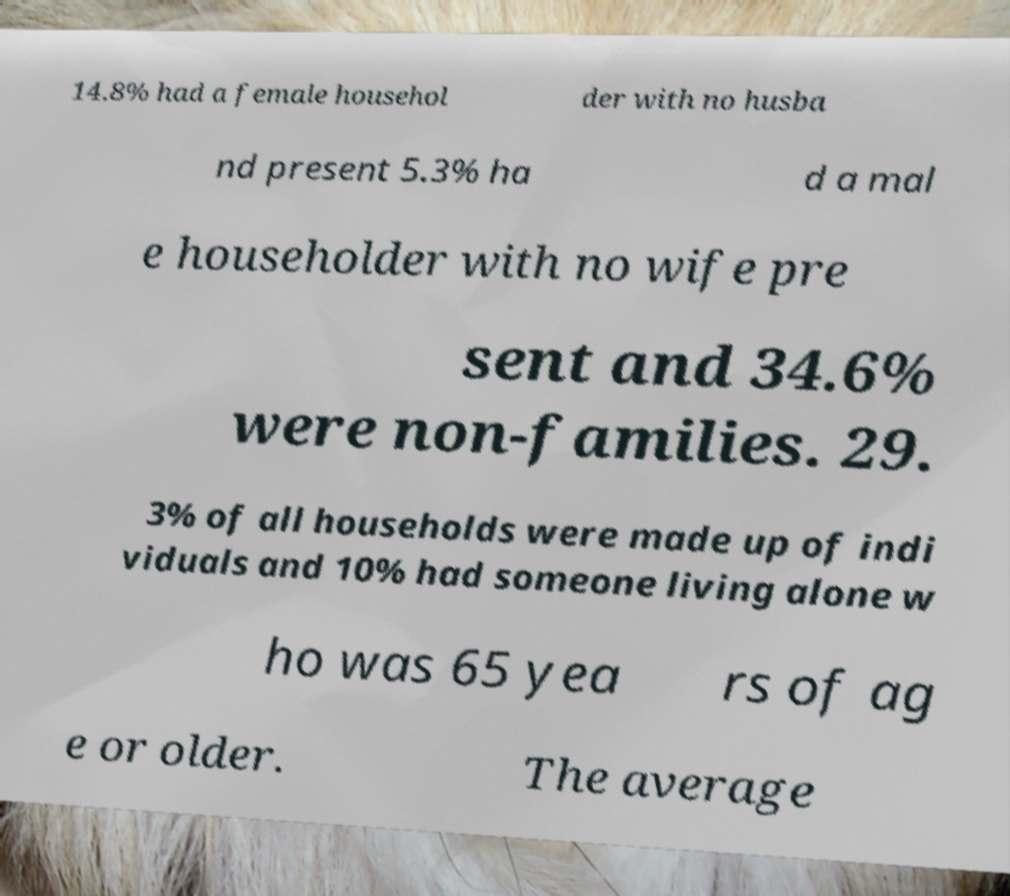Could you extract and type out the text from this image? 14.8% had a female househol der with no husba nd present 5.3% ha d a mal e householder with no wife pre sent and 34.6% were non-families. 29. 3% of all households were made up of indi viduals and 10% had someone living alone w ho was 65 yea rs of ag e or older. The average 